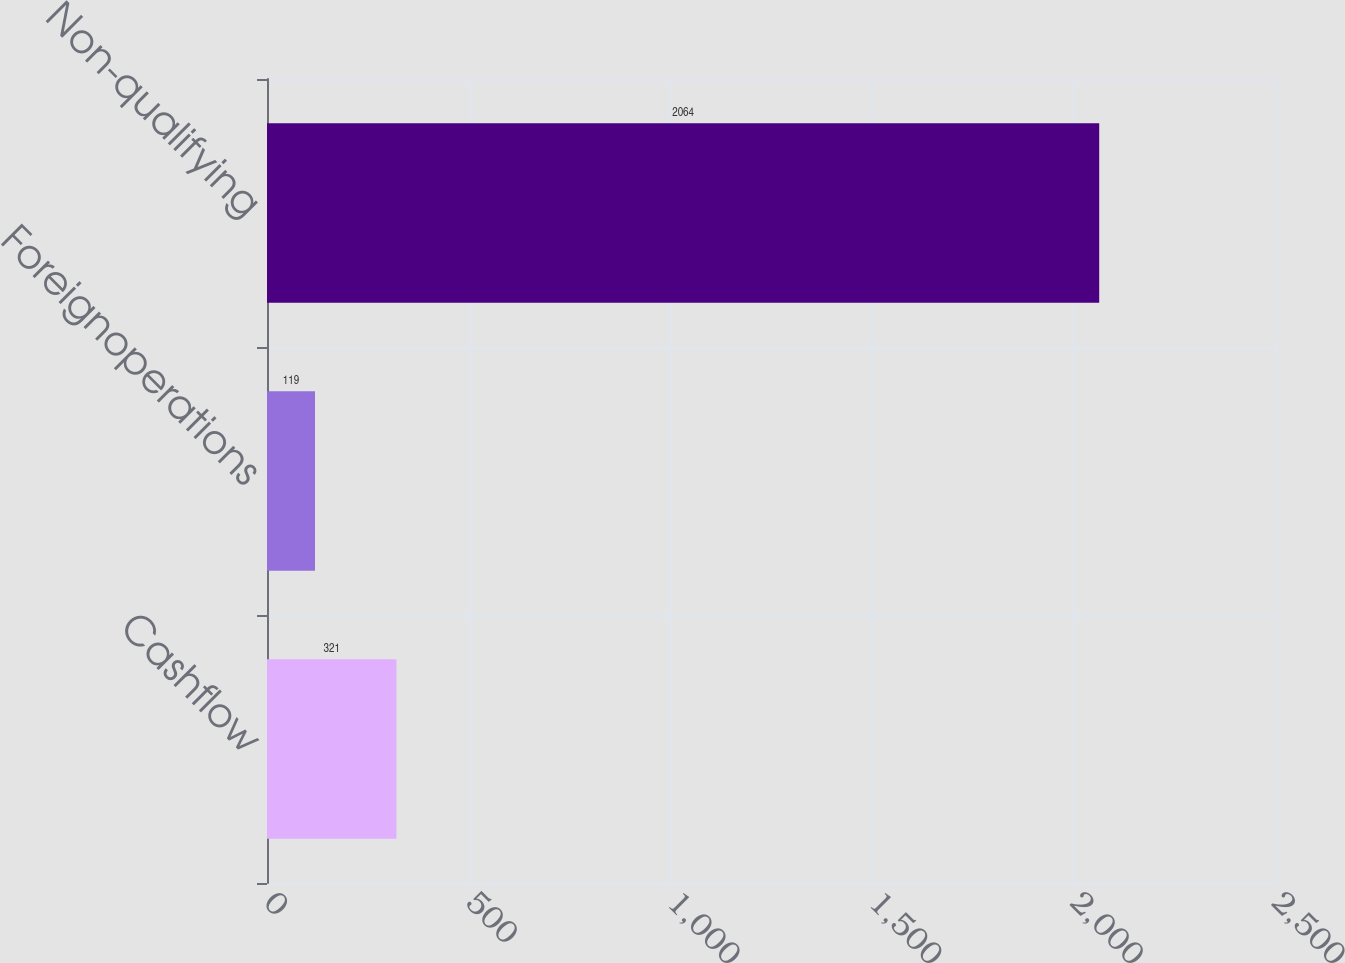Convert chart. <chart><loc_0><loc_0><loc_500><loc_500><bar_chart><fcel>Cashflow<fcel>Foreignoperations<fcel>Non-qualifying<nl><fcel>321<fcel>119<fcel>2064<nl></chart> 